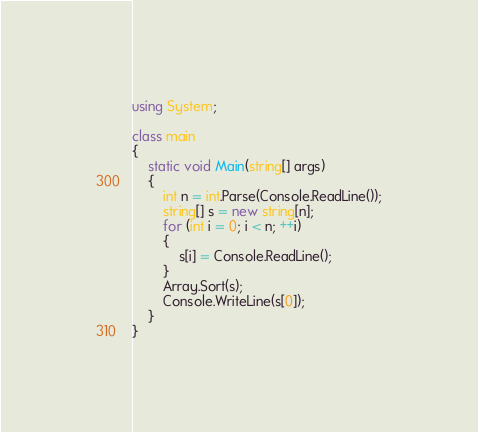Convert code to text. <code><loc_0><loc_0><loc_500><loc_500><_C#_>using System;

class main
{
    static void Main(string[] args)
    {
        int n = int.Parse(Console.ReadLine());
        string[] s = new string[n];
        for (int i = 0; i < n; ++i)
        {
            s[i] = Console.ReadLine();
        }
        Array.Sort(s);
        Console.WriteLine(s[0]);
    }
}</code> 